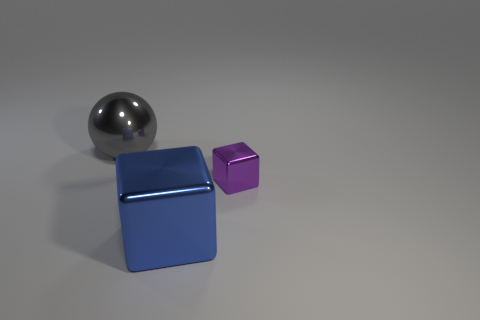There is a block in front of the cube that is behind the object that is in front of the small purple metallic thing; what size is it?
Give a very brief answer. Large. Is the number of shiny objects that are on the right side of the tiny purple cube greater than the number of metallic things that are in front of the big gray sphere?
Your answer should be very brief. No. How many big gray balls are behind the shiny block that is to the left of the tiny block?
Ensure brevity in your answer.  1. Is there a big cube that has the same color as the small shiny object?
Offer a very short reply. No. Is the size of the blue metallic block the same as the gray object?
Offer a terse response. Yes. Do the large metallic ball and the small metallic cube have the same color?
Offer a terse response. No. What is the material of the cube that is left of the purple cube that is behind the blue metal block?
Provide a short and direct response. Metal. There is a big object that is the same shape as the small metal object; what material is it?
Keep it short and to the point. Metal. Does the metallic cube in front of the purple metallic block have the same size as the tiny purple object?
Make the answer very short. No. How many metallic objects are either blocks or large balls?
Your answer should be compact. 3. 